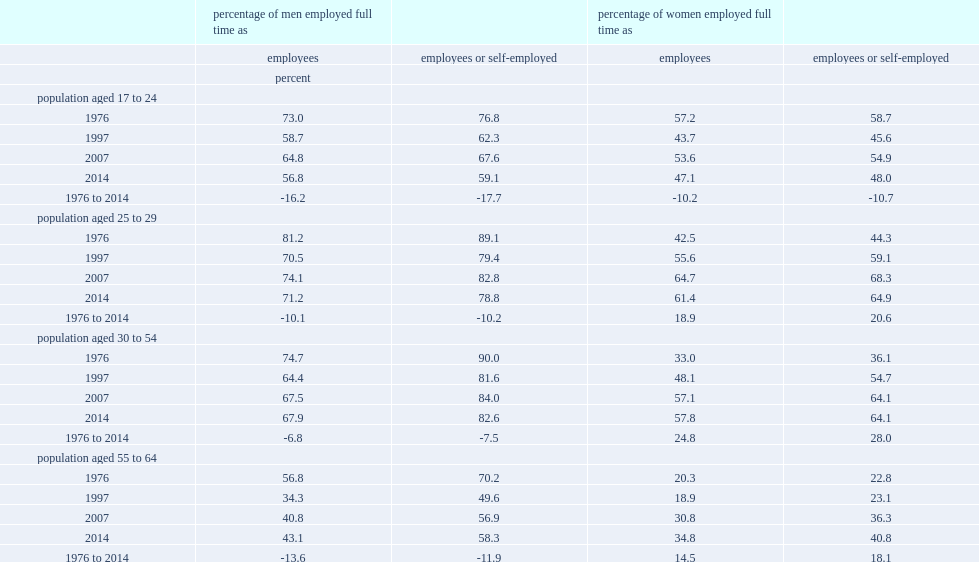From 1976 to 2014, how many percents of the full-time employment rates are declined among men aged 17 to 24 and among women in that age group respectively? -17.7 -10.7. Among men aged 25 to 29, how many percent of the full-time employment rate is declining from 1976 to 2014? 10.2. 